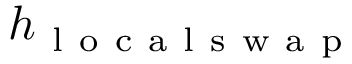Convert formula to latex. <formula><loc_0><loc_0><loc_500><loc_500>h _ { l o c a l s w a p }</formula> 